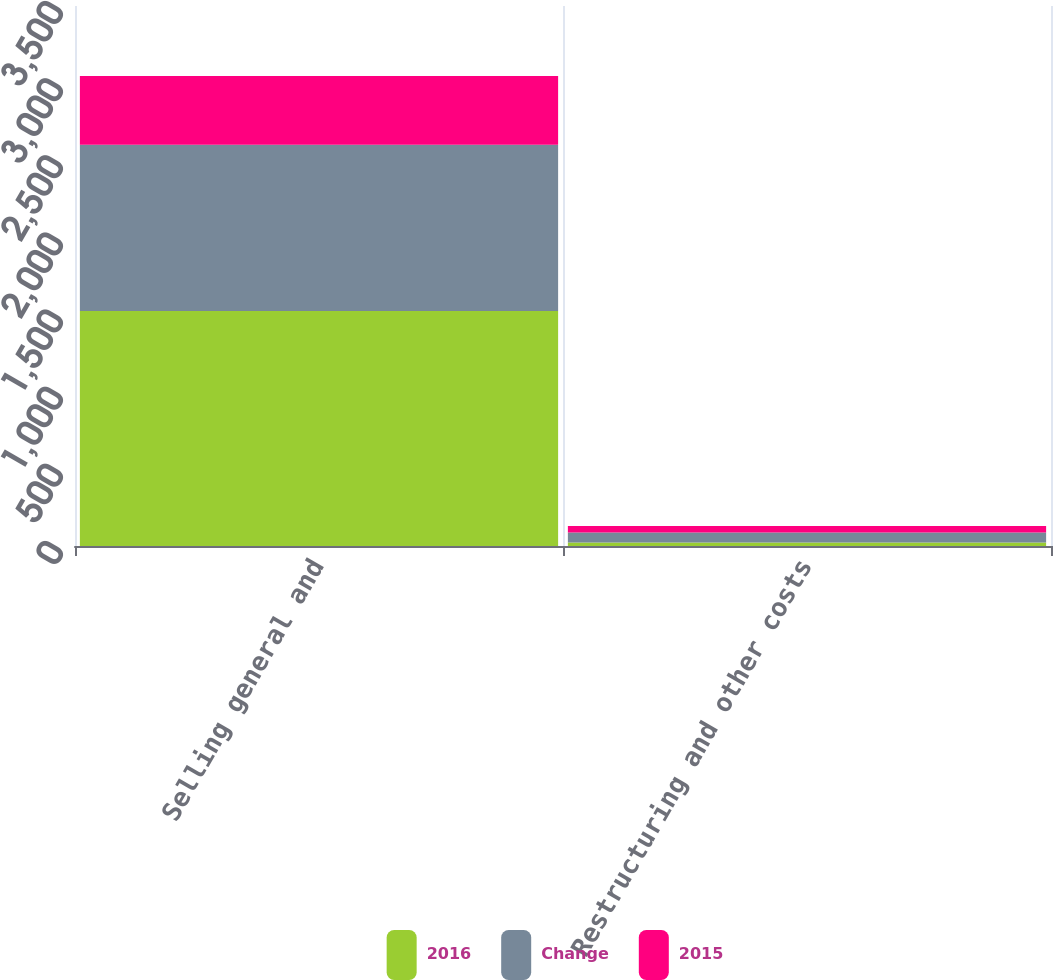<chart> <loc_0><loc_0><loc_500><loc_500><stacked_bar_chart><ecel><fcel>Selling general and<fcel>Restructuring and other costs<nl><fcel>2016<fcel>1523<fcel>23.2<nl><fcel>Change<fcel>1077.3<fcel>64.7<nl><fcel>2015<fcel>445.7<fcel>41.5<nl></chart> 